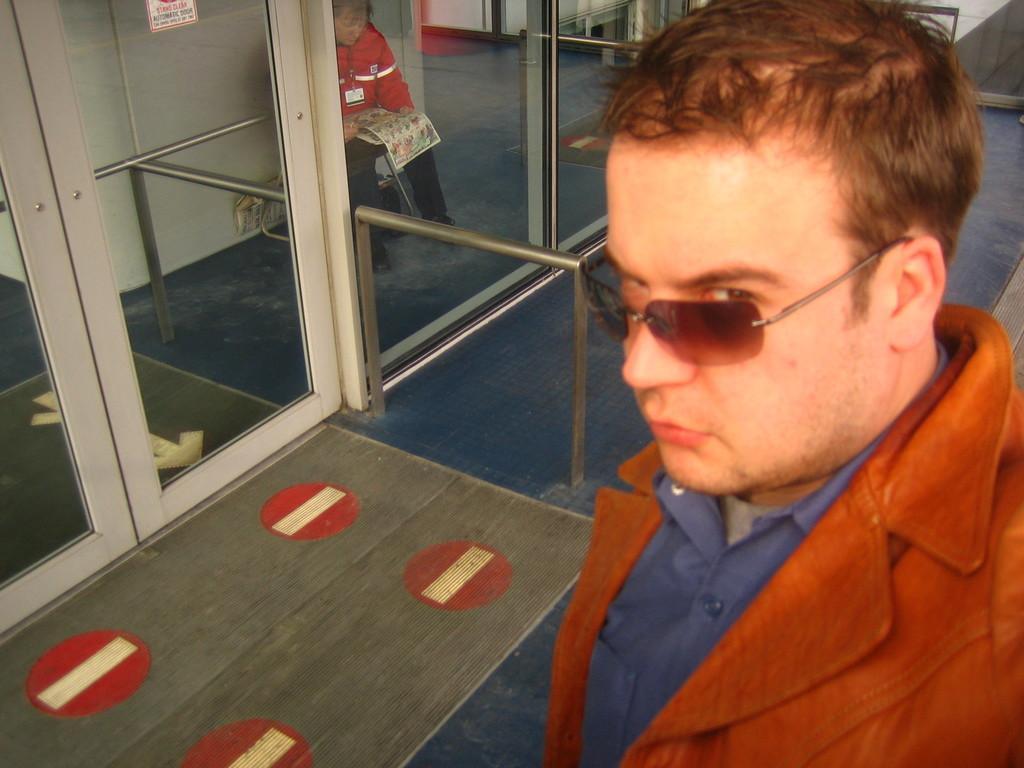Can you describe this image briefly? In this image in the foreground there is one person and at the bottom there is a floor, in the background there is another person who is sitting and he is holding a newspaper and in the center there is a glass door and iron rod. 